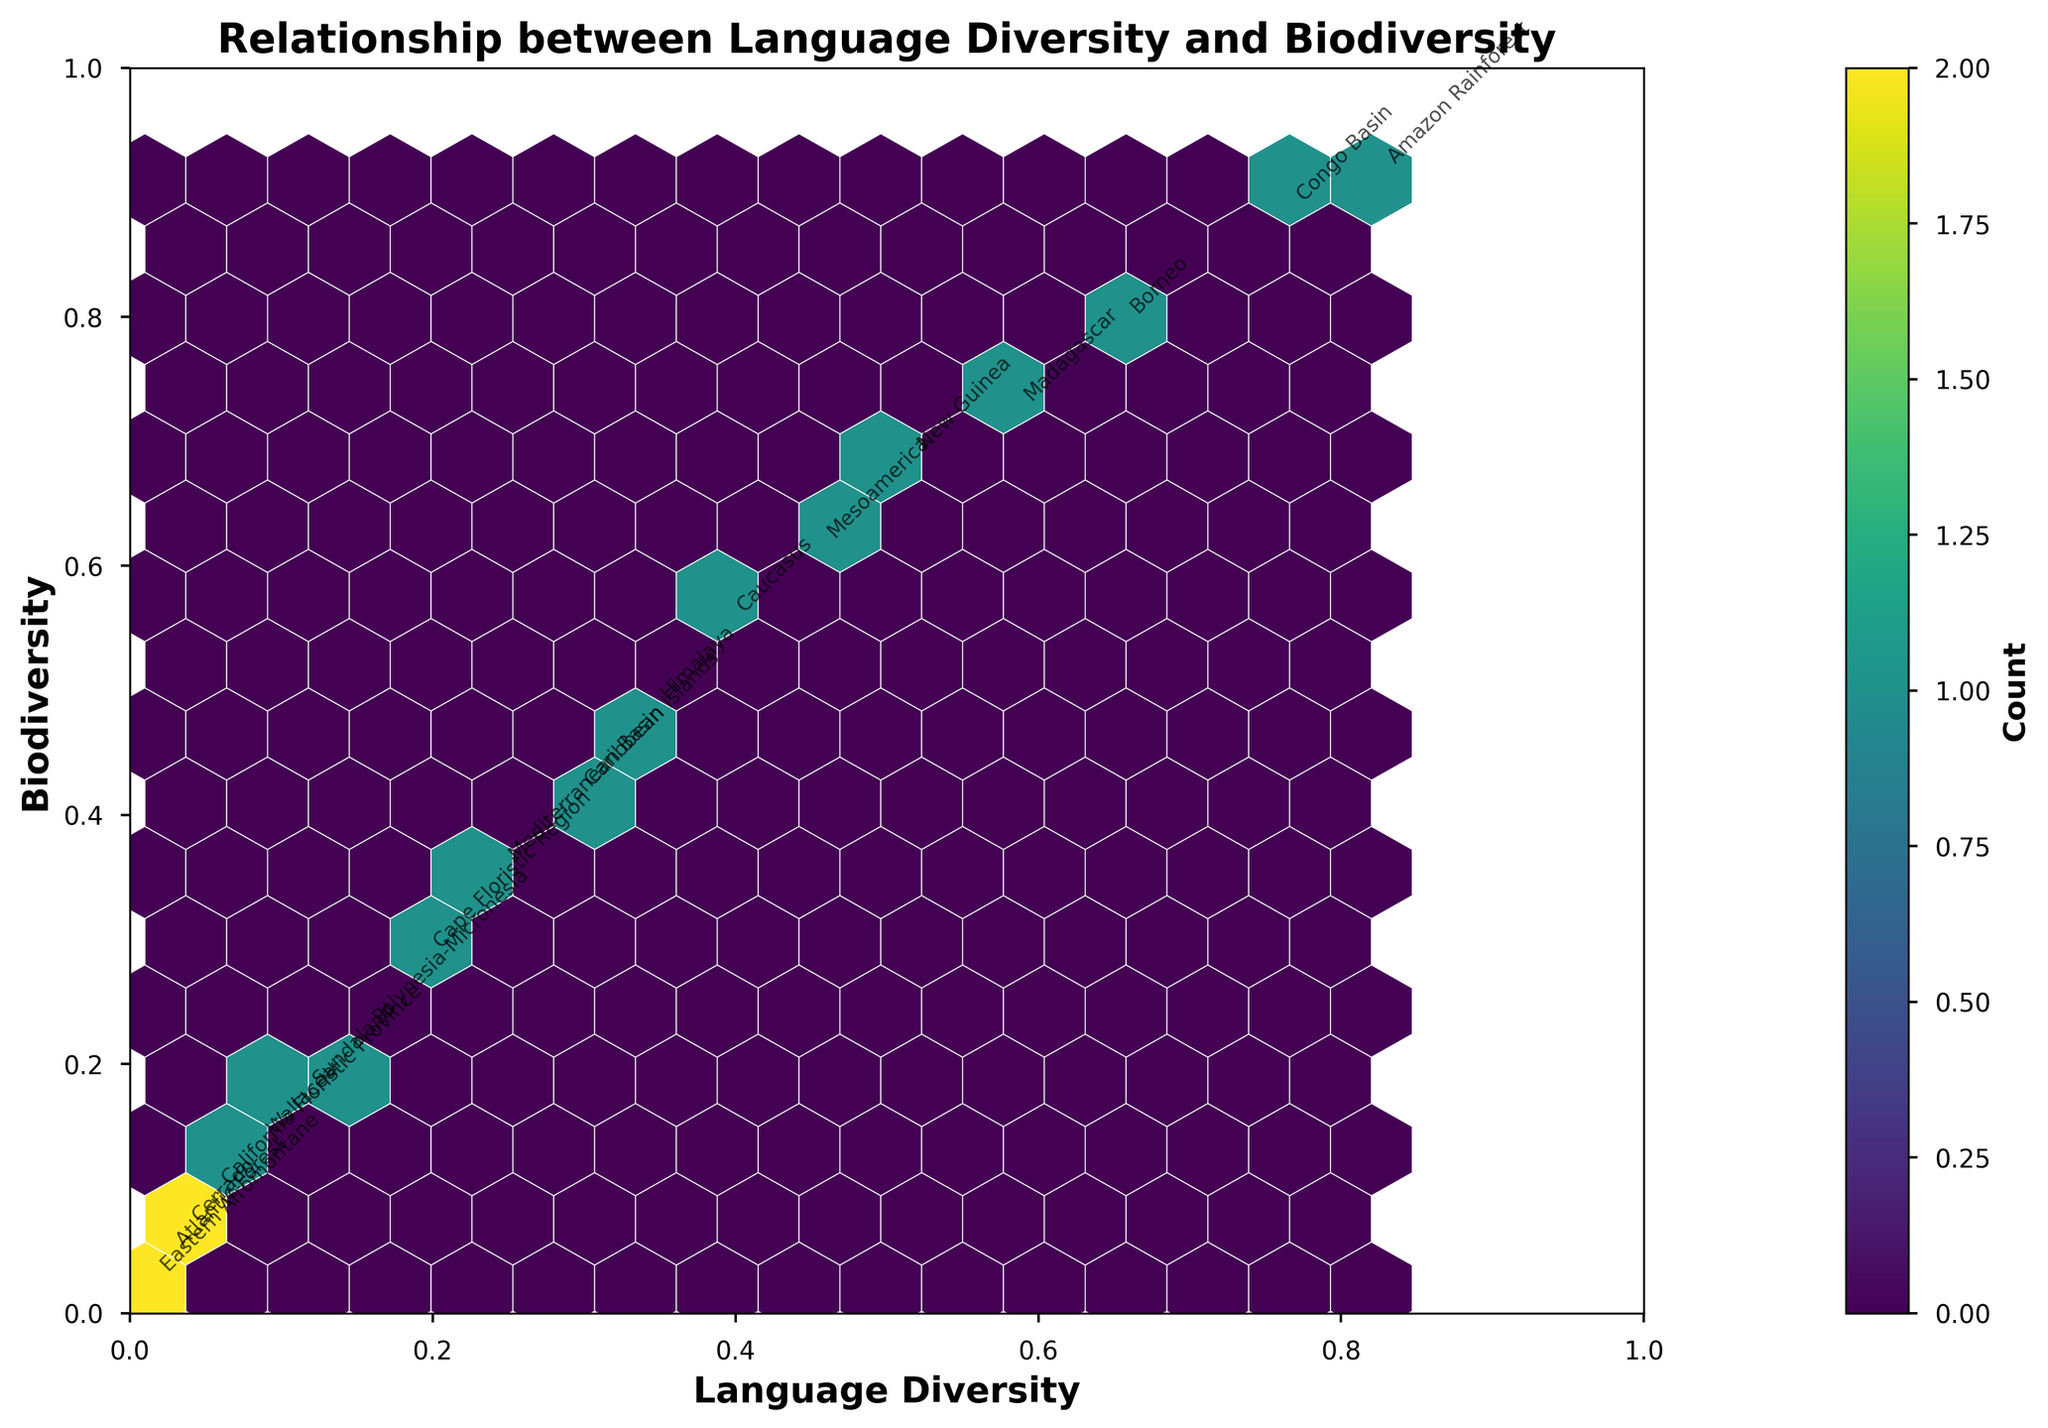What's the title of the figure? The title is usually located at the top of the plot. It provides a summary of what the plot represents. In this case, it states "Relationship between Language Diversity and Biodiversity".
Answer: Relationship between Language Diversity and Biodiversity What is shown on the x-axis? The x-axis label is usually found below the horizontal axis of the plot. It indicates what variable is represented on the horizontal axis. This plot's x-axis shows "Language Diversity".
Answer: Language Diversity What is the color used for the hexagons in the plot? The color of the hexagons can be derived from the color bar or directly from the plot. These colors typically derive from a colormap. In this case, the hexagons are colored using the 'viridis' colormap, which ranges from purple to yellow.
Answer: viridis (purple to yellow) How many hexagons are used in the plot? The number of hexagons can be estimated based on grid size. The provided gridsize is 15, but since it's hexagonal, not all will be visible. This estimation can also be observed directly from the plot visualization.
Answer: Approximately 15 Which region shows the highest biodiversity and language diversity values? Regions can be identified by looking at the annotations near the top-right of the plot. The one closest to the maximum values on both axes is Amazon Rainforest.
Answer: Amazon Rainforest What are the range values for the color bar that represent the count? The color bar is located on the right side of the plot and typically shows the range of counts from lowest to highest. Observing the bar, one can deduce this range.
Answer: From lowest count to highest count Which region has the lowest biodiversity value? The lowest biodiversity value can be found by identifying the lowest point on the y-axis with an annotation. The region here is Eastern Afromontane.
Answer: Eastern Afromontane Compare the language diversity between New Guinea and California Floristic Province. To compare these two regions, find their respective points on the x-axis (language diversity). New Guinea has a higher value compared to California Floristic Province.
Answer: New Guinea has higher language diversity Is there a noticeable trend between language diversity and biodiversity? The trend can be observed by looking at the general direction of the data points. If most points go upwards as you move right, it indicates a positive correlation. There seems to be an upward trend, suggesting higher language diversity correlates with higher biodiversity.
Answer: Positive correlation Which regions are indicated to be in the same hexagon in the plot? Regions in the same hexagon plot close together and often overlap. By observing closely, some regions such as 'Sundaland' and 'Wallacea' might share a data hexagon given their close values.
Answer: Sundaland and Wallacea 